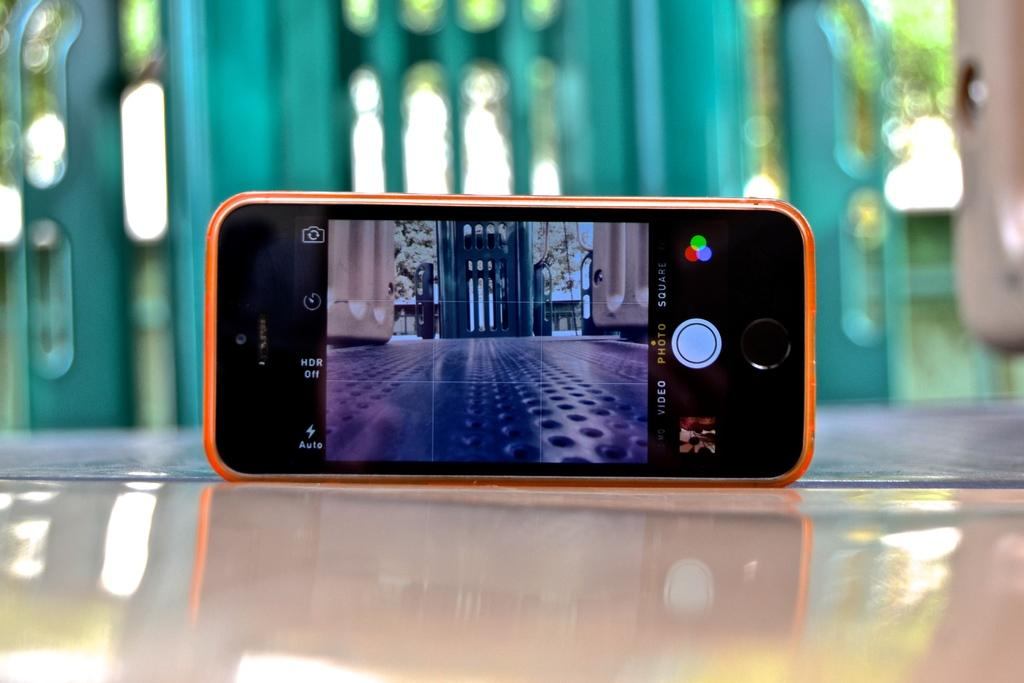<image>
Offer a succinct explanation of the picture presented. a phone that has the word photo at the bottom 